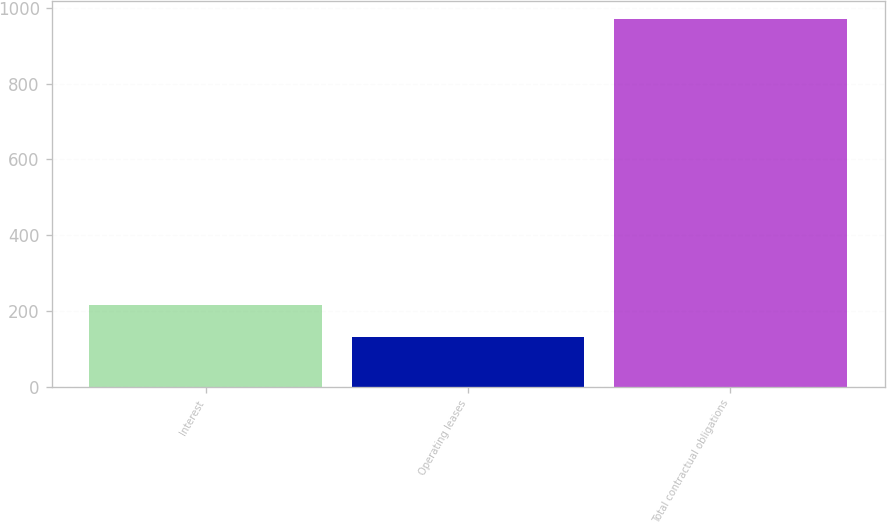Convert chart. <chart><loc_0><loc_0><loc_500><loc_500><bar_chart><fcel>Interest<fcel>Operating leases<fcel>Total contractual obligations<nl><fcel>214.9<fcel>131<fcel>970<nl></chart> 